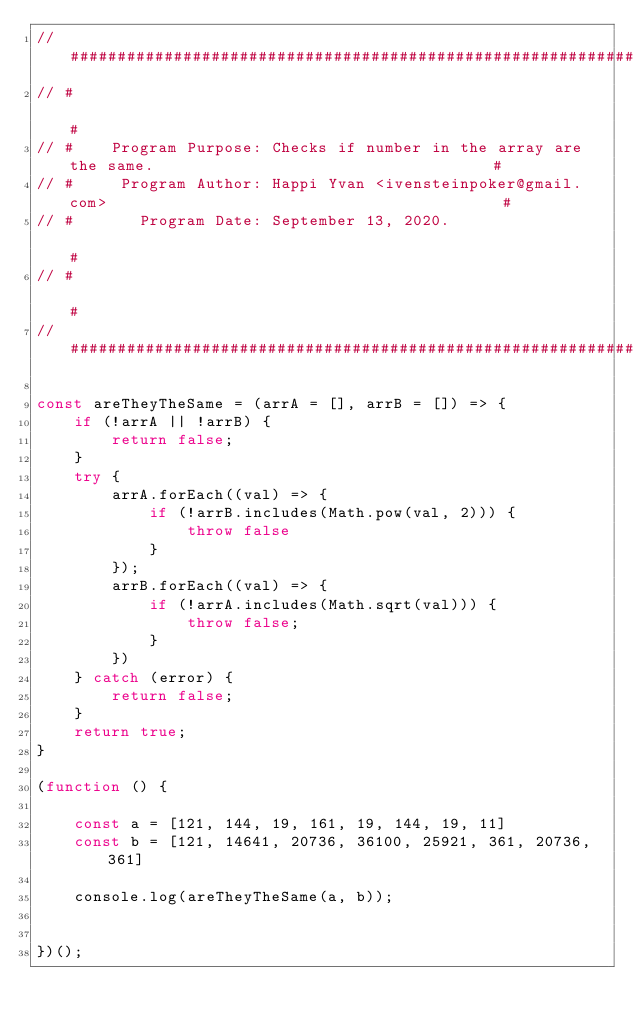Convert code to text. <code><loc_0><loc_0><loc_500><loc_500><_JavaScript_>// ######################################################################################################
// #                                                                                                    #
// #    Program Purpose: Checks if number in the array are the same.                                    #
// #     Program Author: Happi Yvan <ivensteinpoker@gmail.com>                                          #
// #       Program Date: September 13, 2020.                                                            #
// #                                                                                                    #
// ######################################################################################################

const areTheyTheSame = (arrA = [], arrB = []) => {
	if (!arrA || !arrB) {
		return false;
	}
	try {
		arrA.forEach((val) => {
			if (!arrB.includes(Math.pow(val, 2))) {
				throw false
			}
		});
		arrB.forEach((val) => {
			if (!arrA.includes(Math.sqrt(val))) {
				throw false;
			}
		})
	} catch (error) {
		return false;
	}
	return true;
}

(function () {

	const a = [121, 144, 19, 161, 19, 144, 19, 11]
	const b = [121, 14641, 20736, 36100, 25921, 361, 20736, 361]

	console.log(areTheyTheSame(a, b));


})();</code> 